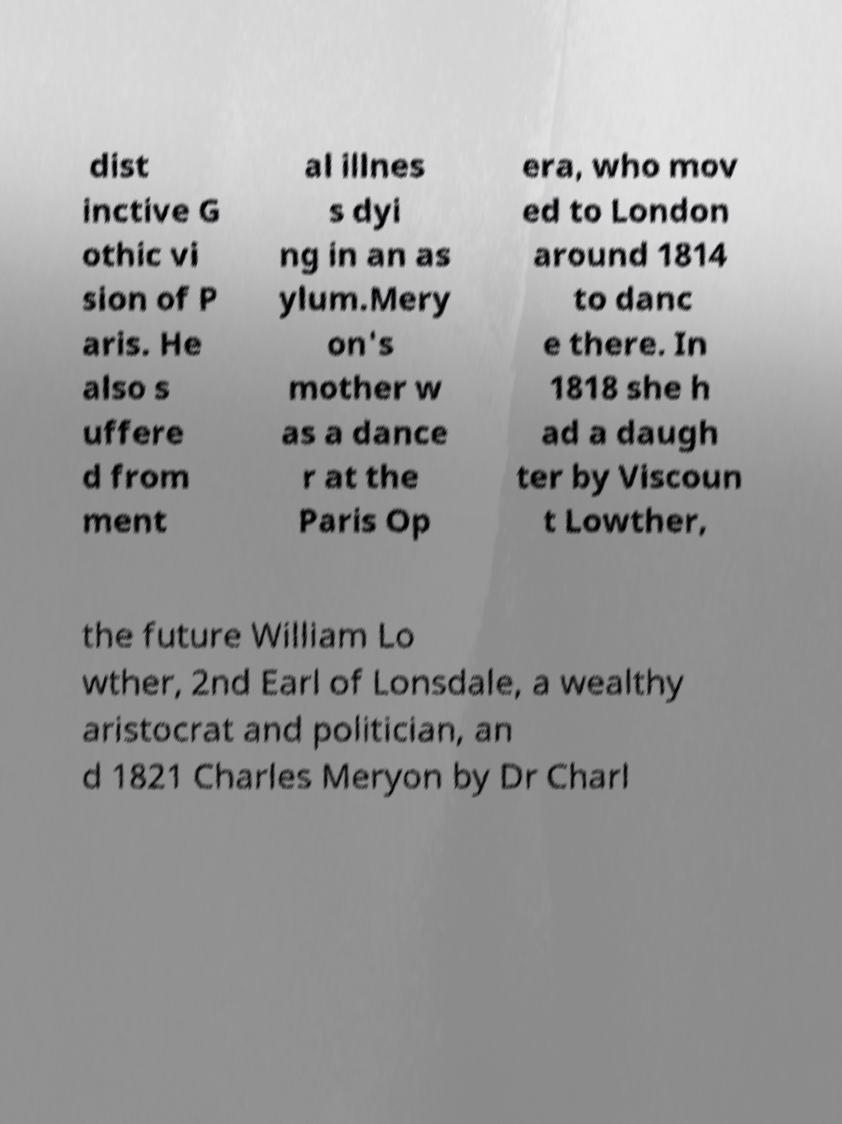There's text embedded in this image that I need extracted. Can you transcribe it verbatim? dist inctive G othic vi sion of P aris. He also s uffere d from ment al illnes s dyi ng in an as ylum.Mery on's mother w as a dance r at the Paris Op era, who mov ed to London around 1814 to danc e there. In 1818 she h ad a daugh ter by Viscoun t Lowther, the future William Lo wther, 2nd Earl of Lonsdale, a wealthy aristocrat and politician, an d 1821 Charles Meryon by Dr Charl 